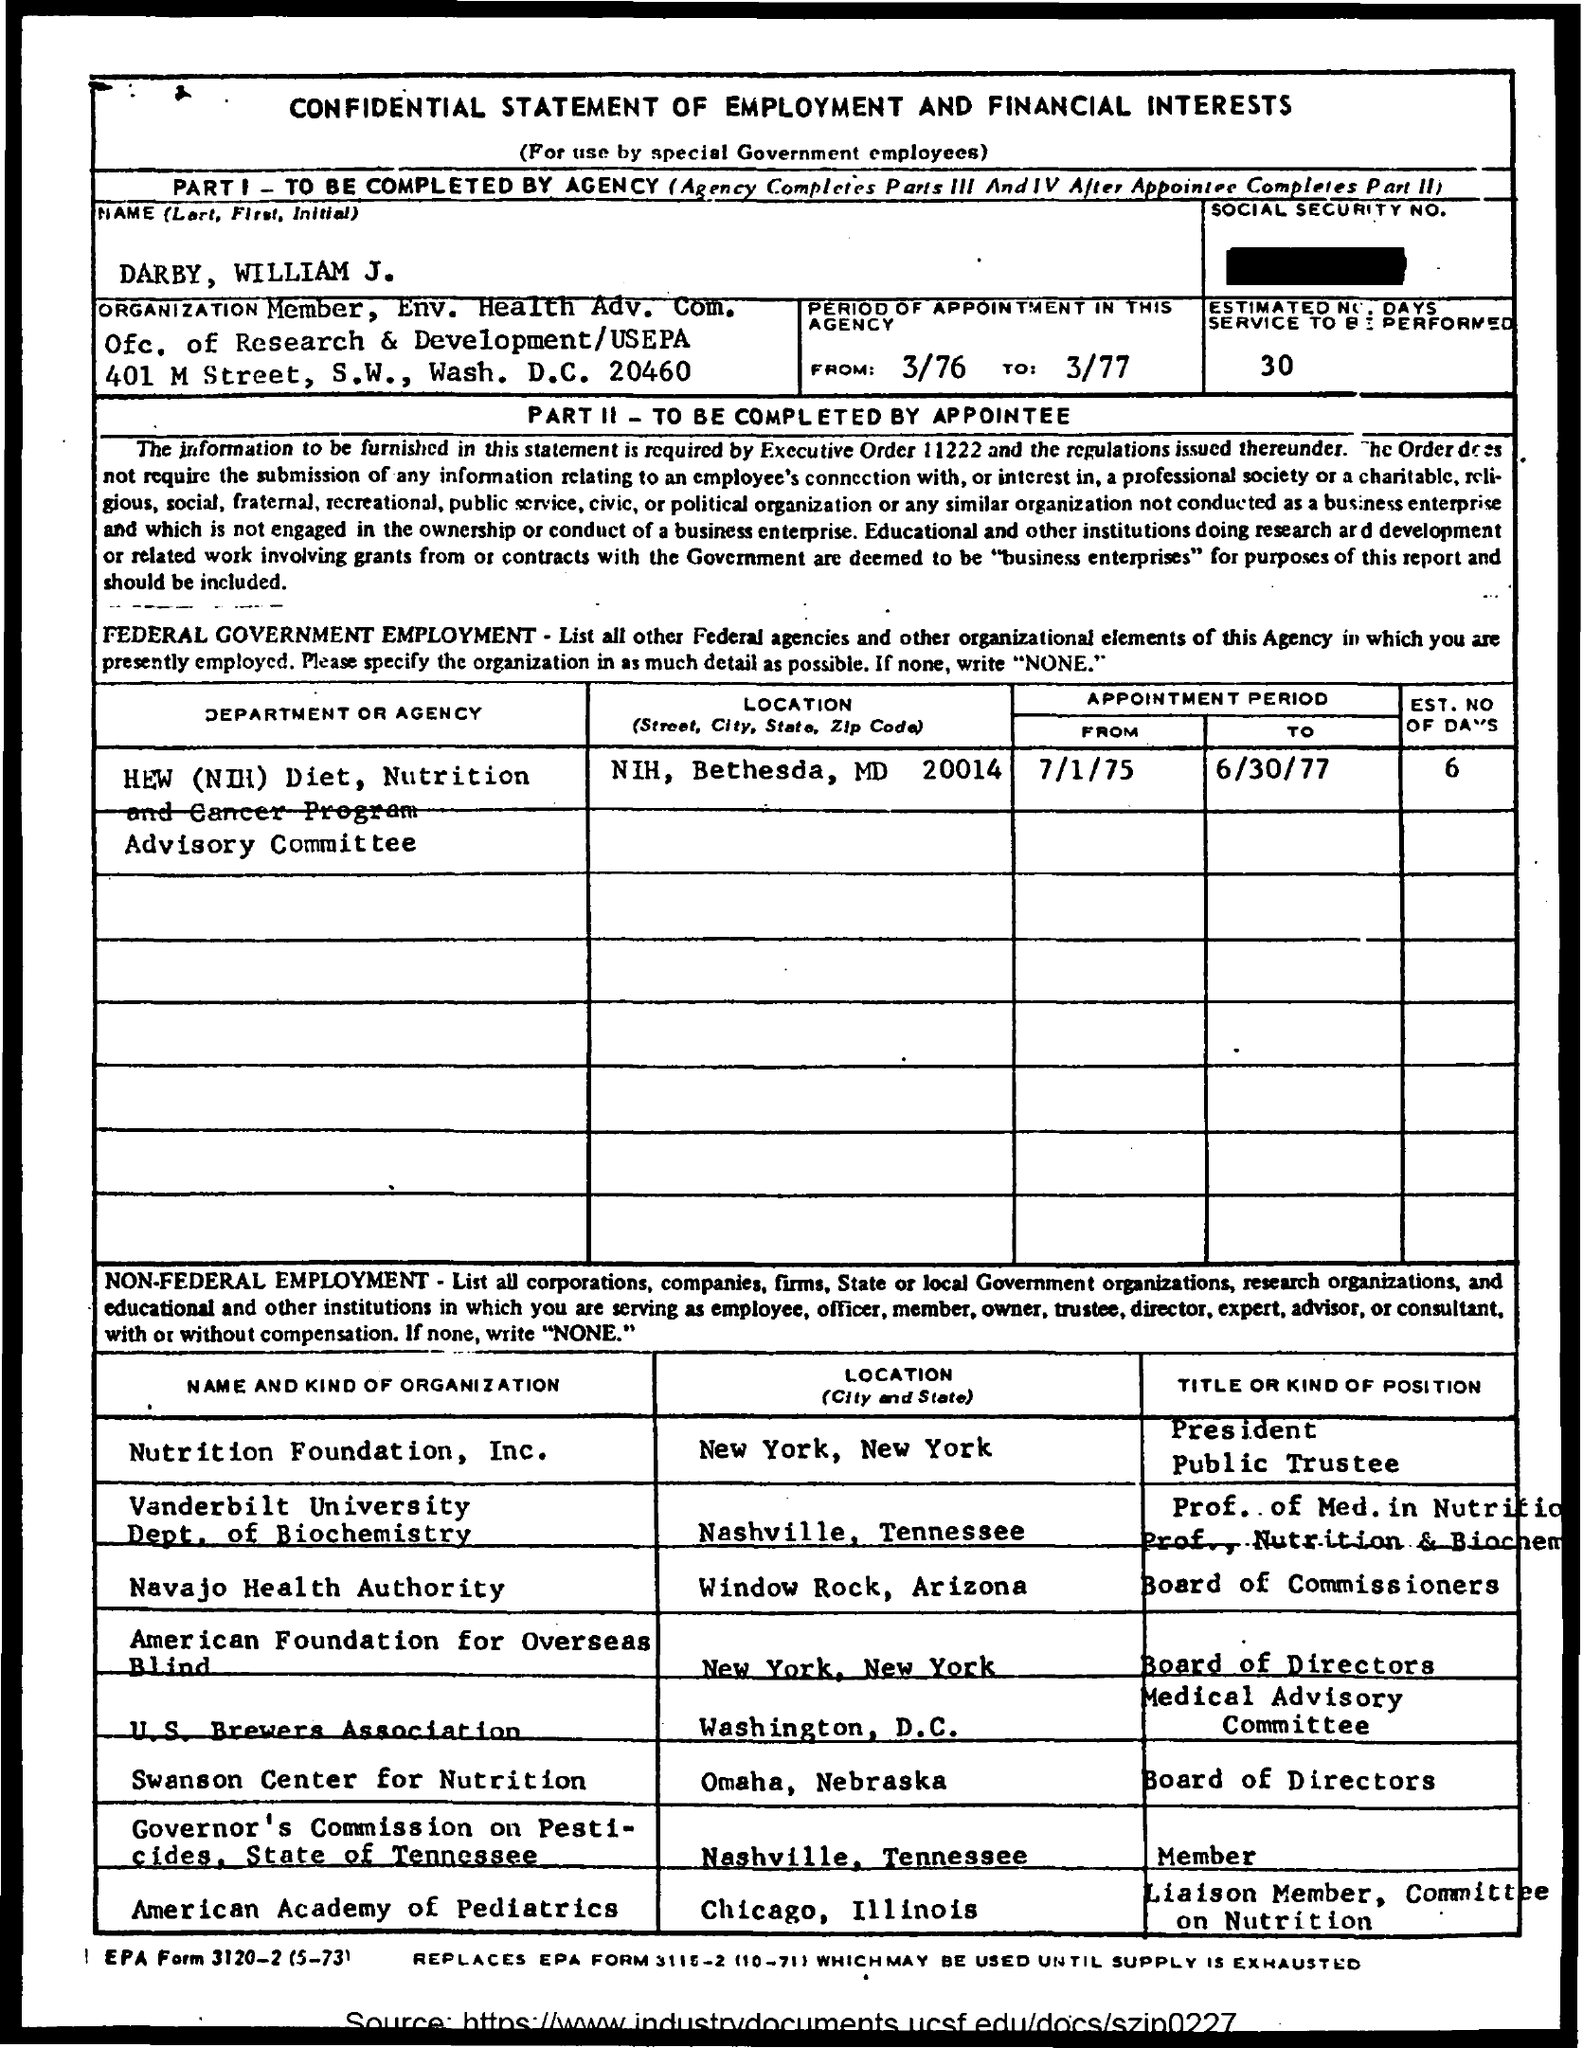Identify some key points in this picture. The Nutrition Foundation, Inc. is located in New York, New York. The location of the American Academy of Pediatrics is Chicago, Illinois. The U.S. Brewers Association is located in Washington, D.C. It is the responsibility of the agency to complete Part I of the form. The Swanson Center for Nutrition is located in Omaha, Nebraska. 